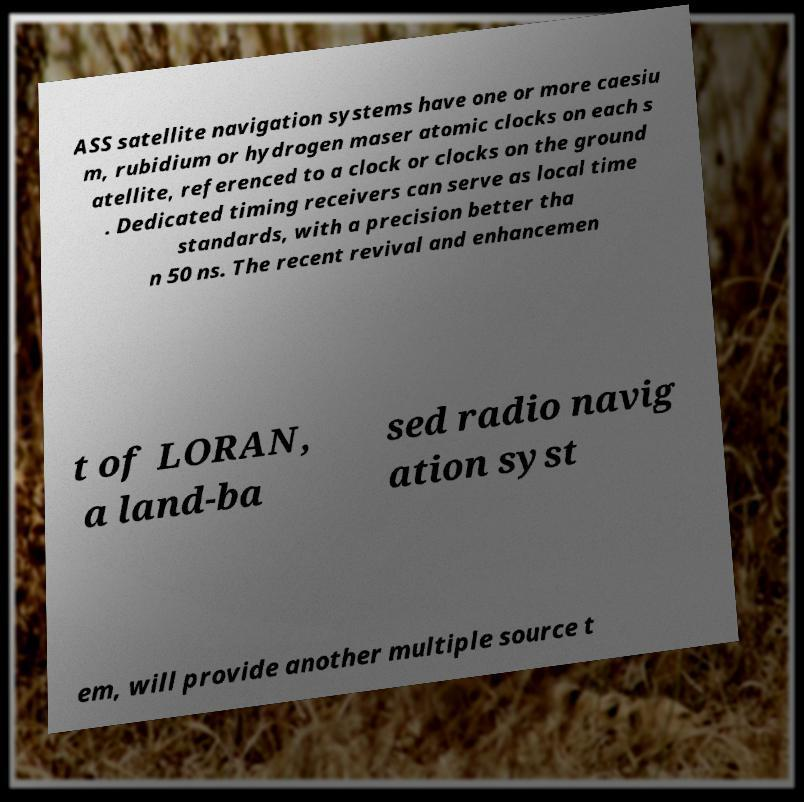Please read and relay the text visible in this image. What does it say? ASS satellite navigation systems have one or more caesiu m, rubidium or hydrogen maser atomic clocks on each s atellite, referenced to a clock or clocks on the ground . Dedicated timing receivers can serve as local time standards, with a precision better tha n 50 ns. The recent revival and enhancemen t of LORAN, a land-ba sed radio navig ation syst em, will provide another multiple source t 